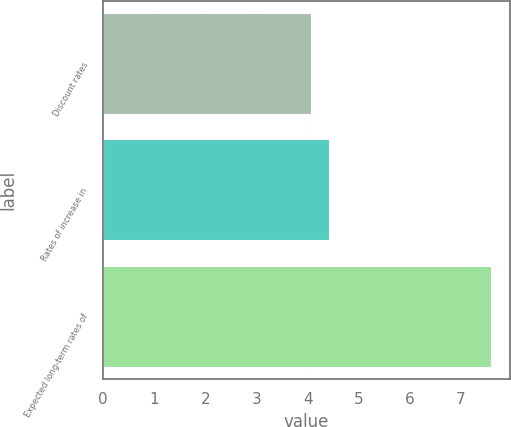<chart> <loc_0><loc_0><loc_500><loc_500><bar_chart><fcel>Discount rates<fcel>Rates of increase in<fcel>Expected long-term rates of<nl><fcel>4.06<fcel>4.41<fcel>7.58<nl></chart> 